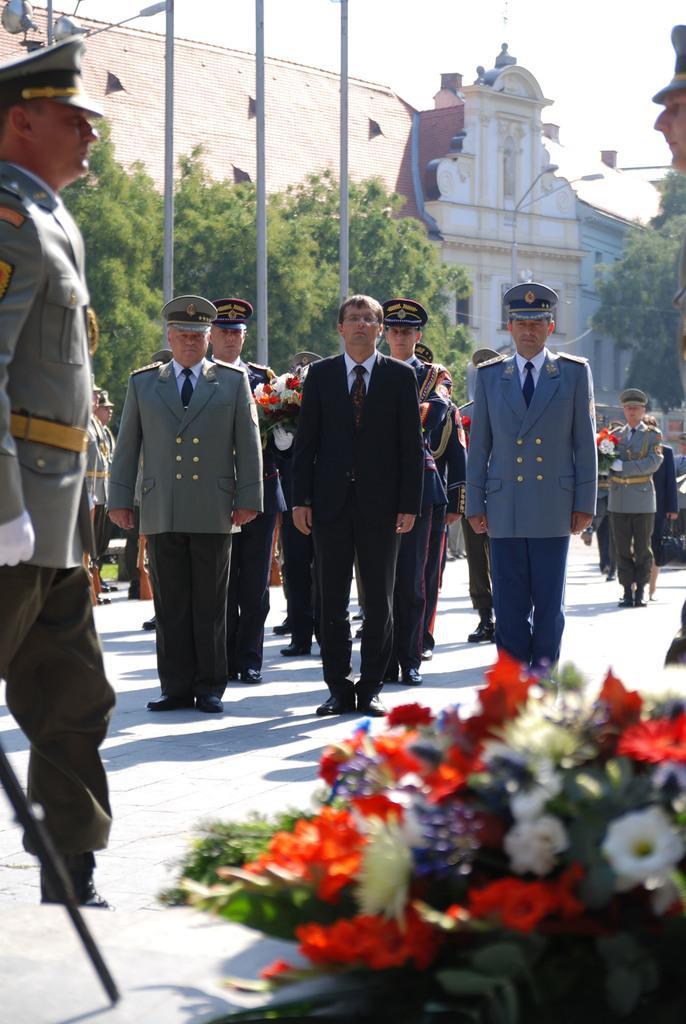Please provide a concise description of this image. In this picture I can see there are few people standing here and they are wearing coats and there is a building in the backdrop and the sky is clear. 